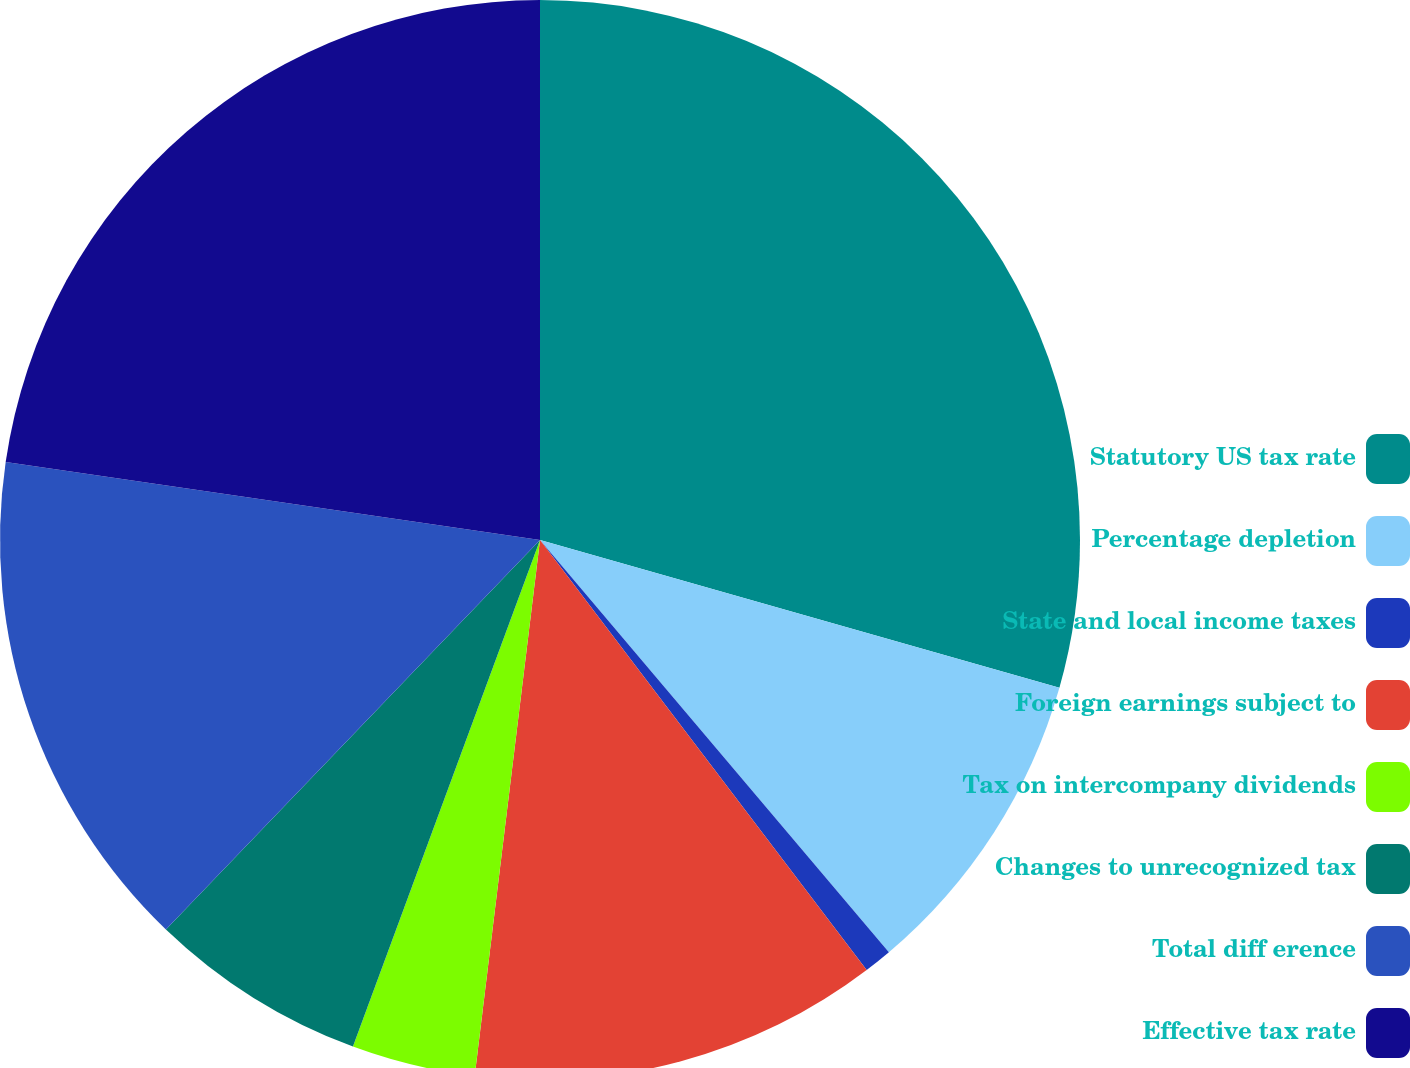Convert chart to OTSL. <chart><loc_0><loc_0><loc_500><loc_500><pie_chart><fcel>Statutory US tax rate<fcel>Percentage depletion<fcel>State and local income taxes<fcel>Foreign earnings subject to<fcel>Tax on intercompany dividends<fcel>Changes to unrecognized tax<fcel>Total diff erence<fcel>Effective tax rate<nl><fcel>29.41%<fcel>9.41%<fcel>0.84%<fcel>12.27%<fcel>3.7%<fcel>6.55%<fcel>15.13%<fcel>22.69%<nl></chart> 